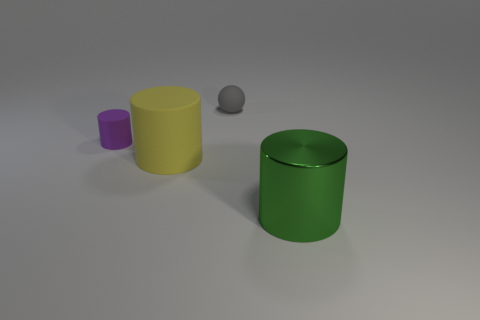What material is the large cylinder in front of the big object that is to the left of the object that is behind the small matte cylinder made of?
Ensure brevity in your answer.  Metal. What number of cylinders are small cyan metallic things or green objects?
Give a very brief answer. 1. Is there anything else that is the same size as the shiny cylinder?
Ensure brevity in your answer.  Yes. There is a large object that is left of the metal object right of the tiny cylinder; how many large yellow cylinders are in front of it?
Your response must be concise. 0. Is the purple thing the same shape as the gray object?
Provide a succinct answer. No. Do the small gray thing behind the big yellow thing and the large object that is to the left of the big green shiny thing have the same material?
Your response must be concise. Yes. How many things are either matte cylinders that are in front of the small purple thing or tiny objects in front of the matte sphere?
Your response must be concise. 2. Is there anything else that has the same shape as the big green thing?
Ensure brevity in your answer.  Yes. What number of blue shiny objects are there?
Keep it short and to the point. 0. Is there a purple matte object that has the same size as the gray object?
Provide a succinct answer. Yes. 